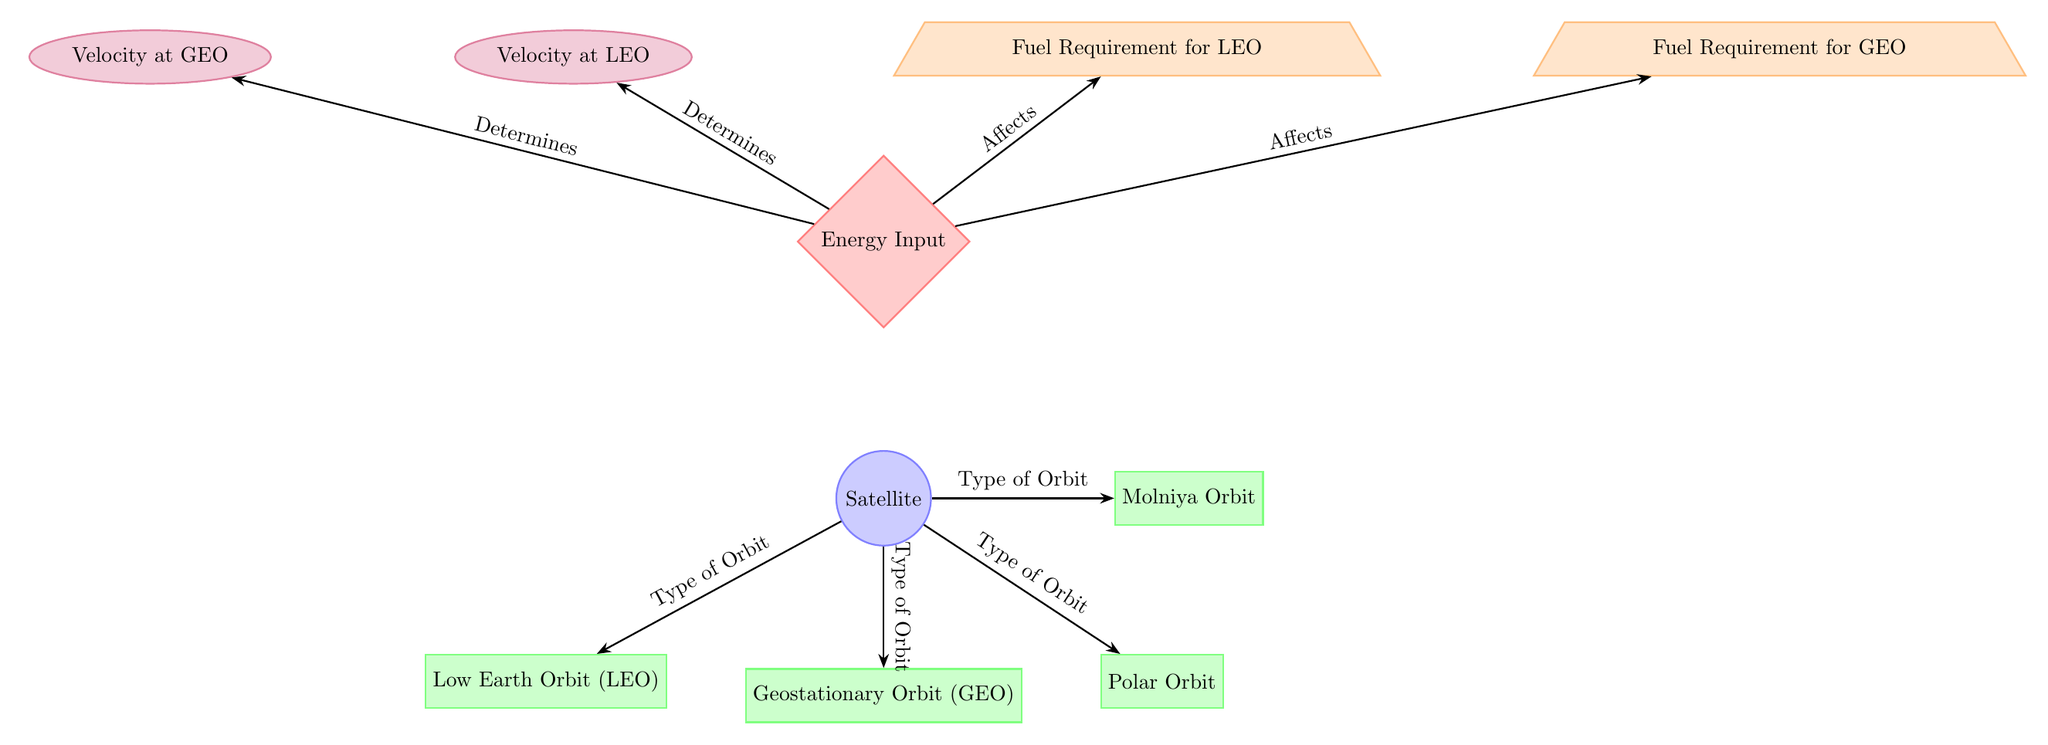What types of orbits are represented in the diagram? The diagram lists four types of orbits: Low Earth Orbit (LEO), Geostationary Orbit (GEO), Polar Orbit, and Molniya Orbit. These are directly indicated by the labels next to the corresponding orbit nodes.
Answer: LEO, GEO, Polar Orbit, Molniya Orbit How many nodes are there representing types of orbits? The diagram contains four orbit nodes, as indicated visually. Each node represents a distinct type of orbit related to the satellite.
Answer: 4 What does the “Energy Input” node affect? The "Energy Input" node has outgoing arrows to "Fuel Requirement for LEO" and "Fuel Requirement for GEO." Therefore, it affects these two nodes, indicating a relationship where energy input influences fuel requirements for these orbits.
Answer: Fuel Requirement for LEO, Fuel Requirement for GEO What is the velocity at Low Earth Orbit (LEO) dependent on? The "Velocity at LEO" node is determined by the "Energy Input" node, which shows that the value or condition of the energy input directly impacts the required velocity at that specific orbit.
Answer: Energy Input Which type of orbit requires the most fuel based on the diagram? The diagram does not explicitly compare fuel requirements among different orbits, but it presents "Fuel Requirement for LEO" and "Fuel Requirement for GEO". Typically, fuel requirements are higher for GEO satellites due to more energy needed to maintain their position. The presence of two fuel nodes suggests a greater emphasis on GEO's requirement.
Answer: Fuel Requirement for GEO How does the energy input relate to velocity at Geostationary Orbit (GEO)? The "Energy Input" node determines the "Velocity at GEO." Hence, any change in energy input will directly affect the velocity required to sustain a satellite in geostationary orbit. This reflects the fundamental principle that energy affects motion in orbital mechanics.
Answer: Velocity at GEO What kind of arrow indicates the direction of flow from the energy node to the velocity nodes? The arrows from the "Energy Input" to both velocity nodes ("Velocity at LEO" and "Velocity at GEO") are labeled as "Determines," indicating a direct cause-and-effect relationship. The arrow style is a thick Stealth arrow, commonly used to show direction and influence in diagrams.
Answer: -Stealth arrow How many fuel requirement nodes are listed in the diagram? The diagram indicates two specific fuel requirement nodes: "Fuel Requirement for LEO" and "Fuel Requirement for GEO." These nodes represent the fuel needs associated with satellites in those particular orbits, thus totaling two nodes.
Answer: 2 